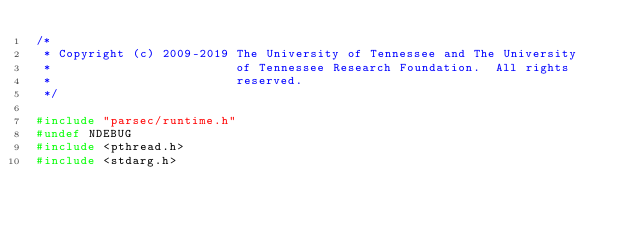Convert code to text. <code><loc_0><loc_0><loc_500><loc_500><_C_>/*
 * Copyright (c) 2009-2019 The University of Tennessee and The University
 *                         of Tennessee Research Foundation.  All rights
 *                         reserved.
 */

#include "parsec/runtime.h"
#undef NDEBUG
#include <pthread.h>
#include <stdarg.h></code> 